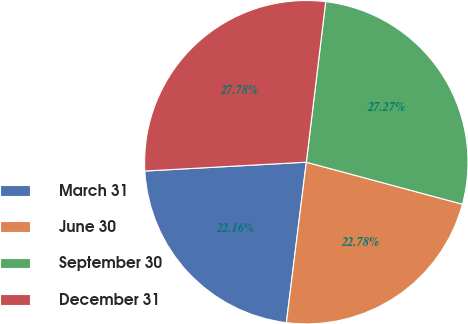Convert chart to OTSL. <chart><loc_0><loc_0><loc_500><loc_500><pie_chart><fcel>March 31<fcel>June 30<fcel>September 30<fcel>December 31<nl><fcel>22.16%<fcel>22.78%<fcel>27.27%<fcel>27.78%<nl></chart> 